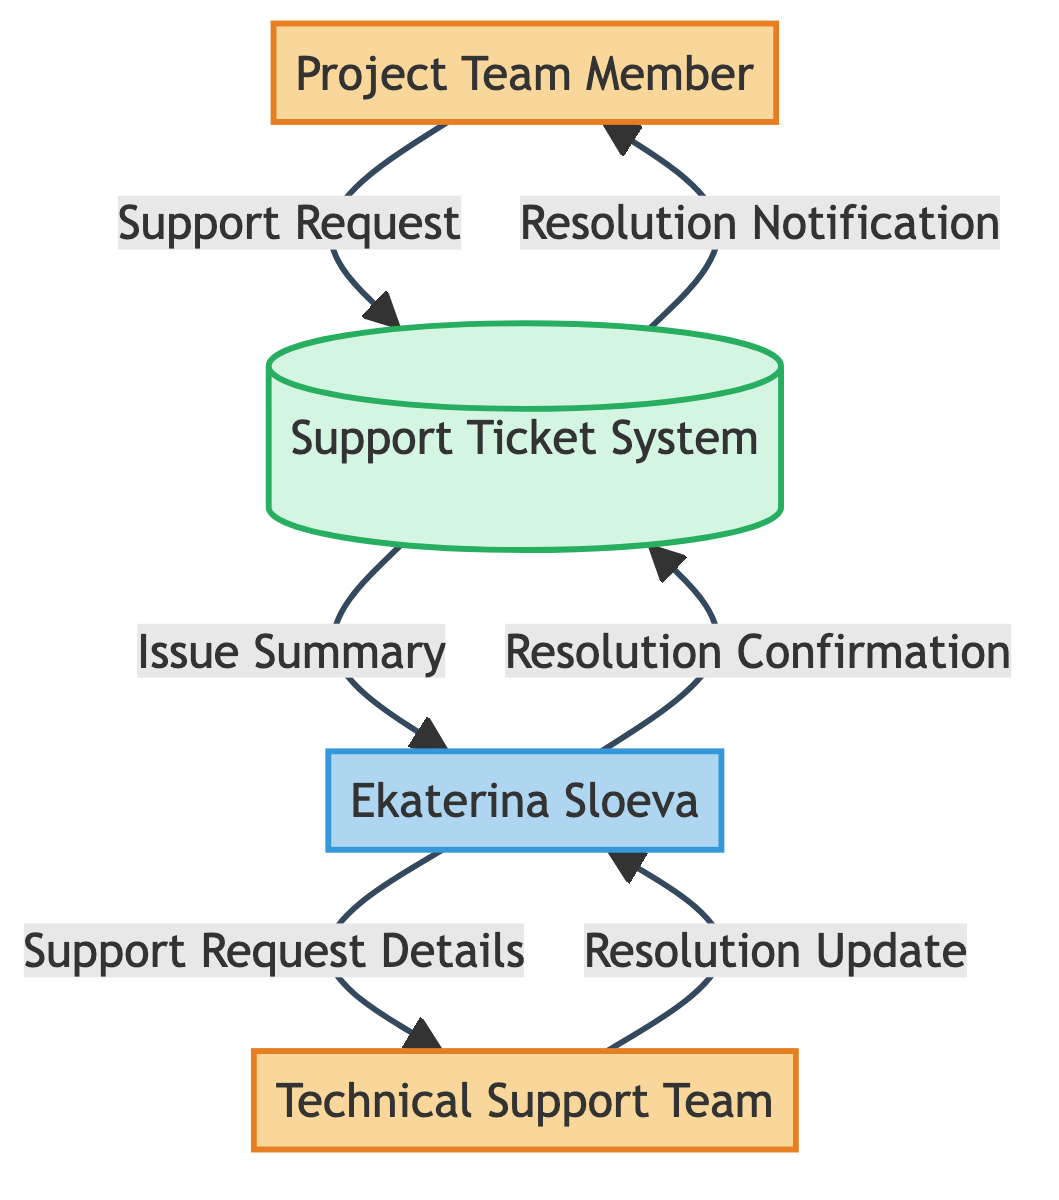What is the first external entity in the diagram? The first external entity listed in the diagram is "Project Team Member." This information is directly available in the entities section of the data provided.
Answer: Project Team Member How many main entities are there in the diagram? The diagram lists four main entities: Project Team Member, Ekaterina Sloeva, Support Ticket System, and Technical Support Team. Counting these entities gives us a total of four.
Answer: 4 What data flow goes from Ekaterina Sloeva to the Support Ticket System? The only data flow from Ekaterina Sloeva to the Support Ticket System is labeled as "Resolution Confirmation." This is identified by tracing the flow direction from Ekaterina Sloeva to the Support Ticket System in the data flow section.
Answer: Resolution Confirmation Which entity receives the "Resolution Notification"? The "Resolution Notification" is received by the "Project Team Member." This can be determined by following the flow from the Support Ticket System to the Project Team Member in the diagram.
Answer: Project Team Member What is the data flow that originates from the Technical Support Team? The data flow originating from the Technical Support Team is labeled "Resolution Update." This is evident as it is the only flow that starts from the Technical Support Team and goes to Ekaterina Sloeva.
Answer: Resolution Update In how many total steps does the support request move through the system? The support request moves through the system in five distinct steps: 1. Project Team Member sends a Support Request, 2. the Support Ticket System receives it and sends an Issue Summary to Ekaterina, 3. Ekaterina then sends Support Request Details to the Technical Support Team, 4. the Technical Support Team sends a Resolution Update back to Ekaterina, and 5. Ekaterina sends a Resolution Confirmation to the Support Ticket System. The final step also results in a Resolution Notification going back to the Project Team Member.
Answer: 6 Which two entities are involved in the flow of "Support Request Details"? The two entities involved in the flow of "Support Request Details" are Ekaterina Sloeva and Technical Support Team. The flow starts from Ekaterina Sloeva and goes to the Technical Support Team.
Answer: Ekaterina Sloeva and Technical Support Team What is the only data store in the diagram? The only data store present in the diagram is the "Support Ticket System." This is explicitly indicated in the entities section of the data structure.
Answer: Support Ticket System How many data flows are shown in the diagram? The diagram displays a total of six data flows. These flows are identified by examining the connections between entities and the data labels in the data flows section.
Answer: 6 